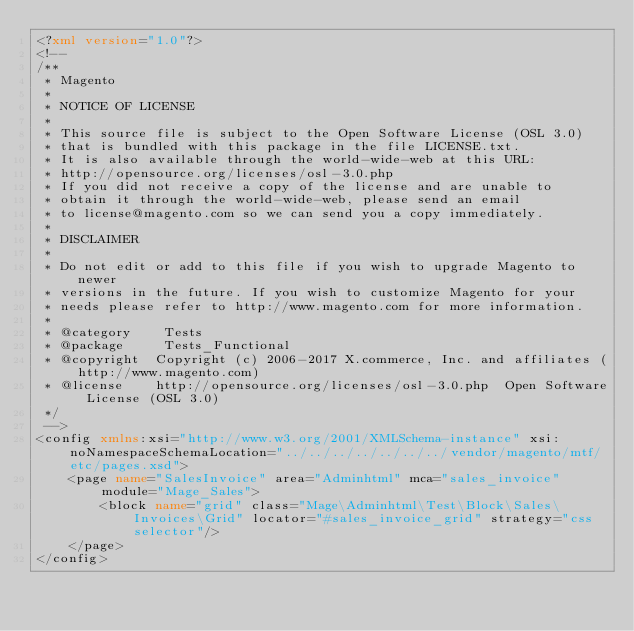<code> <loc_0><loc_0><loc_500><loc_500><_XML_><?xml version="1.0"?>
<!--
/**
 * Magento
 *
 * NOTICE OF LICENSE
 *
 * This source file is subject to the Open Software License (OSL 3.0)
 * that is bundled with this package in the file LICENSE.txt.
 * It is also available through the world-wide-web at this URL:
 * http://opensource.org/licenses/osl-3.0.php
 * If you did not receive a copy of the license and are unable to
 * obtain it through the world-wide-web, please send an email
 * to license@magento.com so we can send you a copy immediately.
 *
 * DISCLAIMER
 *
 * Do not edit or add to this file if you wish to upgrade Magento to newer
 * versions in the future. If you wish to customize Magento for your
 * needs please refer to http://www.magento.com for more information.
 *
 * @category    Tests
 * @package     Tests_Functional
 * @copyright  Copyright (c) 2006-2017 X.commerce, Inc. and affiliates (http://www.magento.com)
 * @license    http://opensource.org/licenses/osl-3.0.php  Open Software License (OSL 3.0)
 */
 -->
<config xmlns:xsi="http://www.w3.org/2001/XMLSchema-instance" xsi:noNamespaceSchemaLocation="../../../../../../../vendor/magento/mtf/etc/pages.xsd">
    <page name="SalesInvoice" area="Adminhtml" mca="sales_invoice" module="Mage_Sales">
        <block name="grid" class="Mage\Adminhtml\Test\Block\Sales\Invoices\Grid" locator="#sales_invoice_grid" strategy="css selector"/>
    </page>
</config>
</code> 